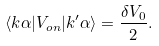<formula> <loc_0><loc_0><loc_500><loc_500>\langle { k } \alpha | V _ { o n } | { k ^ { \prime } } \alpha \rangle = \frac { \delta V _ { 0 } } { 2 } .</formula> 